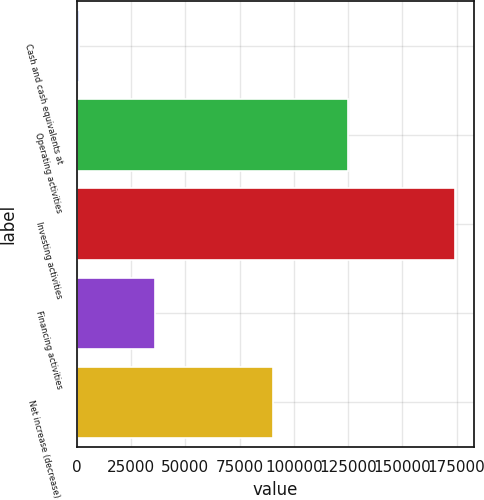Convert chart to OTSL. <chart><loc_0><loc_0><loc_500><loc_500><bar_chart><fcel>Cash and cash equivalents at<fcel>Operating activities<fcel>Investing activities<fcel>Financing activities<fcel>Net increase (decrease) in<nl><fcel>1216<fcel>124811<fcel>174096<fcel>36246<fcel>90235<nl></chart> 